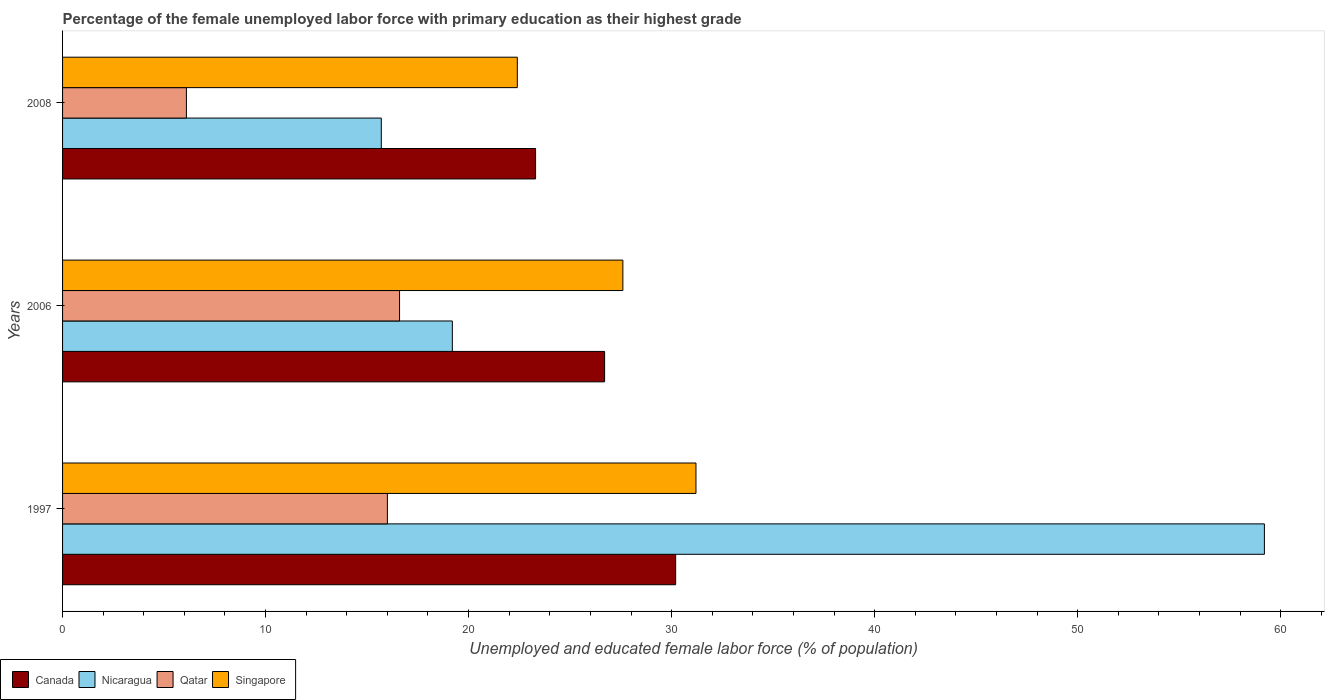How many different coloured bars are there?
Provide a short and direct response. 4. How many groups of bars are there?
Offer a terse response. 3. Are the number of bars per tick equal to the number of legend labels?
Your response must be concise. Yes. What is the percentage of the unemployed female labor force with primary education in Canada in 1997?
Offer a terse response. 30.2. Across all years, what is the maximum percentage of the unemployed female labor force with primary education in Singapore?
Your response must be concise. 31.2. Across all years, what is the minimum percentage of the unemployed female labor force with primary education in Nicaragua?
Offer a very short reply. 15.7. In which year was the percentage of the unemployed female labor force with primary education in Singapore maximum?
Keep it short and to the point. 1997. What is the total percentage of the unemployed female labor force with primary education in Singapore in the graph?
Give a very brief answer. 81.2. What is the difference between the percentage of the unemployed female labor force with primary education in Canada in 2006 and that in 2008?
Offer a very short reply. 3.4. What is the difference between the percentage of the unemployed female labor force with primary education in Canada in 2006 and the percentage of the unemployed female labor force with primary education in Singapore in 1997?
Make the answer very short. -4.5. What is the average percentage of the unemployed female labor force with primary education in Canada per year?
Offer a very short reply. 26.73. In the year 2008, what is the difference between the percentage of the unemployed female labor force with primary education in Nicaragua and percentage of the unemployed female labor force with primary education in Singapore?
Keep it short and to the point. -6.7. In how many years, is the percentage of the unemployed female labor force with primary education in Singapore greater than 40 %?
Offer a terse response. 0. What is the ratio of the percentage of the unemployed female labor force with primary education in Canada in 1997 to that in 2008?
Provide a short and direct response. 1.3. Is the percentage of the unemployed female labor force with primary education in Canada in 1997 less than that in 2008?
Your answer should be very brief. No. What is the difference between the highest and the second highest percentage of the unemployed female labor force with primary education in Singapore?
Your answer should be very brief. 3.6. What is the difference between the highest and the lowest percentage of the unemployed female labor force with primary education in Singapore?
Keep it short and to the point. 8.8. Is it the case that in every year, the sum of the percentage of the unemployed female labor force with primary education in Canada and percentage of the unemployed female labor force with primary education in Qatar is greater than the sum of percentage of the unemployed female labor force with primary education in Singapore and percentage of the unemployed female labor force with primary education in Nicaragua?
Your answer should be very brief. No. What does the 3rd bar from the top in 2006 represents?
Your response must be concise. Nicaragua. What does the 4th bar from the bottom in 2006 represents?
Give a very brief answer. Singapore. Are all the bars in the graph horizontal?
Your answer should be very brief. Yes. Does the graph contain any zero values?
Give a very brief answer. No. Where does the legend appear in the graph?
Your answer should be compact. Bottom left. How many legend labels are there?
Your answer should be very brief. 4. How are the legend labels stacked?
Make the answer very short. Horizontal. What is the title of the graph?
Keep it short and to the point. Percentage of the female unemployed labor force with primary education as their highest grade. Does "Kiribati" appear as one of the legend labels in the graph?
Offer a terse response. No. What is the label or title of the X-axis?
Provide a short and direct response. Unemployed and educated female labor force (% of population). What is the Unemployed and educated female labor force (% of population) of Canada in 1997?
Your answer should be very brief. 30.2. What is the Unemployed and educated female labor force (% of population) of Nicaragua in 1997?
Give a very brief answer. 59.2. What is the Unemployed and educated female labor force (% of population) in Singapore in 1997?
Your answer should be compact. 31.2. What is the Unemployed and educated female labor force (% of population) in Canada in 2006?
Your answer should be compact. 26.7. What is the Unemployed and educated female labor force (% of population) in Nicaragua in 2006?
Make the answer very short. 19.2. What is the Unemployed and educated female labor force (% of population) of Qatar in 2006?
Offer a very short reply. 16.6. What is the Unemployed and educated female labor force (% of population) in Singapore in 2006?
Provide a succinct answer. 27.6. What is the Unemployed and educated female labor force (% of population) of Canada in 2008?
Make the answer very short. 23.3. What is the Unemployed and educated female labor force (% of population) of Nicaragua in 2008?
Keep it short and to the point. 15.7. What is the Unemployed and educated female labor force (% of population) of Qatar in 2008?
Give a very brief answer. 6.1. What is the Unemployed and educated female labor force (% of population) in Singapore in 2008?
Offer a terse response. 22.4. Across all years, what is the maximum Unemployed and educated female labor force (% of population) in Canada?
Give a very brief answer. 30.2. Across all years, what is the maximum Unemployed and educated female labor force (% of population) of Nicaragua?
Keep it short and to the point. 59.2. Across all years, what is the maximum Unemployed and educated female labor force (% of population) in Qatar?
Keep it short and to the point. 16.6. Across all years, what is the maximum Unemployed and educated female labor force (% of population) in Singapore?
Make the answer very short. 31.2. Across all years, what is the minimum Unemployed and educated female labor force (% of population) of Canada?
Provide a succinct answer. 23.3. Across all years, what is the minimum Unemployed and educated female labor force (% of population) of Nicaragua?
Your answer should be very brief. 15.7. Across all years, what is the minimum Unemployed and educated female labor force (% of population) in Qatar?
Provide a short and direct response. 6.1. Across all years, what is the minimum Unemployed and educated female labor force (% of population) of Singapore?
Provide a short and direct response. 22.4. What is the total Unemployed and educated female labor force (% of population) in Canada in the graph?
Your answer should be very brief. 80.2. What is the total Unemployed and educated female labor force (% of population) of Nicaragua in the graph?
Ensure brevity in your answer.  94.1. What is the total Unemployed and educated female labor force (% of population) in Qatar in the graph?
Provide a short and direct response. 38.7. What is the total Unemployed and educated female labor force (% of population) of Singapore in the graph?
Ensure brevity in your answer.  81.2. What is the difference between the Unemployed and educated female labor force (% of population) of Singapore in 1997 and that in 2006?
Your answer should be compact. 3.6. What is the difference between the Unemployed and educated female labor force (% of population) of Nicaragua in 1997 and that in 2008?
Offer a terse response. 43.5. What is the difference between the Unemployed and educated female labor force (% of population) of Qatar in 1997 and that in 2008?
Make the answer very short. 9.9. What is the difference between the Unemployed and educated female labor force (% of population) in Canada in 2006 and that in 2008?
Your response must be concise. 3.4. What is the difference between the Unemployed and educated female labor force (% of population) in Nicaragua in 2006 and that in 2008?
Offer a terse response. 3.5. What is the difference between the Unemployed and educated female labor force (% of population) of Canada in 1997 and the Unemployed and educated female labor force (% of population) of Nicaragua in 2006?
Your answer should be compact. 11. What is the difference between the Unemployed and educated female labor force (% of population) of Canada in 1997 and the Unemployed and educated female labor force (% of population) of Qatar in 2006?
Offer a terse response. 13.6. What is the difference between the Unemployed and educated female labor force (% of population) in Nicaragua in 1997 and the Unemployed and educated female labor force (% of population) in Qatar in 2006?
Offer a very short reply. 42.6. What is the difference between the Unemployed and educated female labor force (% of population) in Nicaragua in 1997 and the Unemployed and educated female labor force (% of population) in Singapore in 2006?
Your response must be concise. 31.6. What is the difference between the Unemployed and educated female labor force (% of population) in Qatar in 1997 and the Unemployed and educated female labor force (% of population) in Singapore in 2006?
Your answer should be compact. -11.6. What is the difference between the Unemployed and educated female labor force (% of population) in Canada in 1997 and the Unemployed and educated female labor force (% of population) in Qatar in 2008?
Provide a succinct answer. 24.1. What is the difference between the Unemployed and educated female labor force (% of population) in Nicaragua in 1997 and the Unemployed and educated female labor force (% of population) in Qatar in 2008?
Keep it short and to the point. 53.1. What is the difference between the Unemployed and educated female labor force (% of population) of Nicaragua in 1997 and the Unemployed and educated female labor force (% of population) of Singapore in 2008?
Keep it short and to the point. 36.8. What is the difference between the Unemployed and educated female labor force (% of population) in Canada in 2006 and the Unemployed and educated female labor force (% of population) in Qatar in 2008?
Give a very brief answer. 20.6. What is the difference between the Unemployed and educated female labor force (% of population) of Nicaragua in 2006 and the Unemployed and educated female labor force (% of population) of Singapore in 2008?
Provide a short and direct response. -3.2. What is the difference between the Unemployed and educated female labor force (% of population) of Qatar in 2006 and the Unemployed and educated female labor force (% of population) of Singapore in 2008?
Keep it short and to the point. -5.8. What is the average Unemployed and educated female labor force (% of population) in Canada per year?
Offer a very short reply. 26.73. What is the average Unemployed and educated female labor force (% of population) in Nicaragua per year?
Make the answer very short. 31.37. What is the average Unemployed and educated female labor force (% of population) of Qatar per year?
Make the answer very short. 12.9. What is the average Unemployed and educated female labor force (% of population) of Singapore per year?
Ensure brevity in your answer.  27.07. In the year 1997, what is the difference between the Unemployed and educated female labor force (% of population) of Canada and Unemployed and educated female labor force (% of population) of Qatar?
Keep it short and to the point. 14.2. In the year 1997, what is the difference between the Unemployed and educated female labor force (% of population) in Nicaragua and Unemployed and educated female labor force (% of population) in Qatar?
Keep it short and to the point. 43.2. In the year 1997, what is the difference between the Unemployed and educated female labor force (% of population) of Qatar and Unemployed and educated female labor force (% of population) of Singapore?
Your answer should be very brief. -15.2. In the year 2006, what is the difference between the Unemployed and educated female labor force (% of population) of Canada and Unemployed and educated female labor force (% of population) of Nicaragua?
Provide a succinct answer. 7.5. In the year 2006, what is the difference between the Unemployed and educated female labor force (% of population) of Nicaragua and Unemployed and educated female labor force (% of population) of Qatar?
Make the answer very short. 2.6. In the year 2006, what is the difference between the Unemployed and educated female labor force (% of population) in Qatar and Unemployed and educated female labor force (% of population) in Singapore?
Your response must be concise. -11. In the year 2008, what is the difference between the Unemployed and educated female labor force (% of population) in Canada and Unemployed and educated female labor force (% of population) in Nicaragua?
Provide a succinct answer. 7.6. In the year 2008, what is the difference between the Unemployed and educated female labor force (% of population) in Canada and Unemployed and educated female labor force (% of population) in Qatar?
Provide a succinct answer. 17.2. In the year 2008, what is the difference between the Unemployed and educated female labor force (% of population) in Canada and Unemployed and educated female labor force (% of population) in Singapore?
Offer a very short reply. 0.9. In the year 2008, what is the difference between the Unemployed and educated female labor force (% of population) of Nicaragua and Unemployed and educated female labor force (% of population) of Qatar?
Offer a very short reply. 9.6. In the year 2008, what is the difference between the Unemployed and educated female labor force (% of population) of Nicaragua and Unemployed and educated female labor force (% of population) of Singapore?
Ensure brevity in your answer.  -6.7. In the year 2008, what is the difference between the Unemployed and educated female labor force (% of population) of Qatar and Unemployed and educated female labor force (% of population) of Singapore?
Offer a very short reply. -16.3. What is the ratio of the Unemployed and educated female labor force (% of population) in Canada in 1997 to that in 2006?
Keep it short and to the point. 1.13. What is the ratio of the Unemployed and educated female labor force (% of population) of Nicaragua in 1997 to that in 2006?
Ensure brevity in your answer.  3.08. What is the ratio of the Unemployed and educated female labor force (% of population) of Qatar in 1997 to that in 2006?
Provide a short and direct response. 0.96. What is the ratio of the Unemployed and educated female labor force (% of population) of Singapore in 1997 to that in 2006?
Offer a very short reply. 1.13. What is the ratio of the Unemployed and educated female labor force (% of population) in Canada in 1997 to that in 2008?
Keep it short and to the point. 1.3. What is the ratio of the Unemployed and educated female labor force (% of population) in Nicaragua in 1997 to that in 2008?
Ensure brevity in your answer.  3.77. What is the ratio of the Unemployed and educated female labor force (% of population) in Qatar in 1997 to that in 2008?
Ensure brevity in your answer.  2.62. What is the ratio of the Unemployed and educated female labor force (% of population) in Singapore in 1997 to that in 2008?
Provide a short and direct response. 1.39. What is the ratio of the Unemployed and educated female labor force (% of population) of Canada in 2006 to that in 2008?
Your answer should be very brief. 1.15. What is the ratio of the Unemployed and educated female labor force (% of population) of Nicaragua in 2006 to that in 2008?
Your answer should be compact. 1.22. What is the ratio of the Unemployed and educated female labor force (% of population) of Qatar in 2006 to that in 2008?
Offer a very short reply. 2.72. What is the ratio of the Unemployed and educated female labor force (% of population) in Singapore in 2006 to that in 2008?
Give a very brief answer. 1.23. What is the difference between the highest and the second highest Unemployed and educated female labor force (% of population) of Qatar?
Provide a succinct answer. 0.6. What is the difference between the highest and the second highest Unemployed and educated female labor force (% of population) in Singapore?
Offer a very short reply. 3.6. What is the difference between the highest and the lowest Unemployed and educated female labor force (% of population) of Canada?
Your answer should be very brief. 6.9. What is the difference between the highest and the lowest Unemployed and educated female labor force (% of population) of Nicaragua?
Keep it short and to the point. 43.5. What is the difference between the highest and the lowest Unemployed and educated female labor force (% of population) in Singapore?
Ensure brevity in your answer.  8.8. 